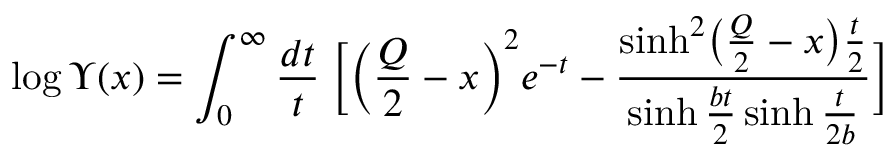<formula> <loc_0><loc_0><loc_500><loc_500>\log \Upsilon ( x ) = \int _ { 0 } ^ { \infty } \frac { d t } { t } \, \left [ \left ( \frac { Q } { 2 } - x \right ) ^ { 2 } e ^ { - t } - \frac { \sinh ^ { 2 } \left ( \frac { Q } { 2 } - x \right ) \frac { t } { 2 } } { \sinh \frac { b t } { 2 } \sinh \frac { t } { 2 b } } \right ]</formula> 